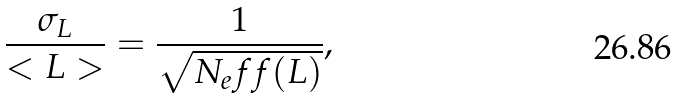Convert formula to latex. <formula><loc_0><loc_0><loc_500><loc_500>\frac { \sigma _ { L } } { < L > } = \frac { 1 } { \sqrt { N _ { e } f f ( L ) } } ,</formula> 